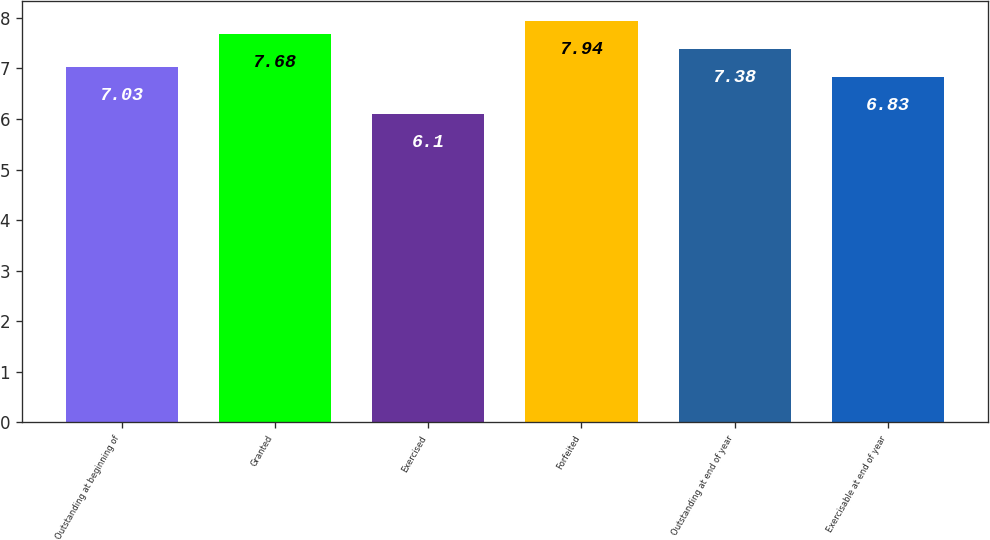<chart> <loc_0><loc_0><loc_500><loc_500><bar_chart><fcel>Outstanding at beginning of<fcel>Granted<fcel>Exercised<fcel>Forfeited<fcel>Outstanding at end of year<fcel>Exercisable at end of year<nl><fcel>7.03<fcel>7.68<fcel>6.1<fcel>7.94<fcel>7.38<fcel>6.83<nl></chart> 